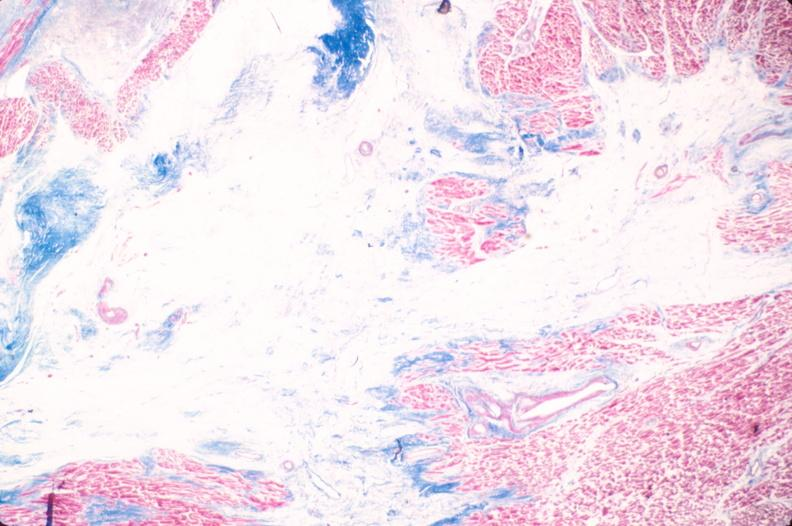what is present?
Answer the question using a single word or phrase. Cardiovascular 